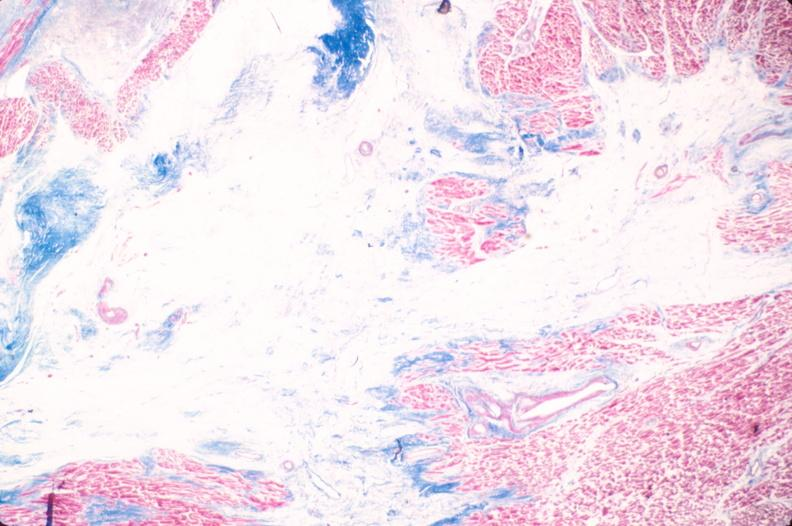what is present?
Answer the question using a single word or phrase. Cardiovascular 